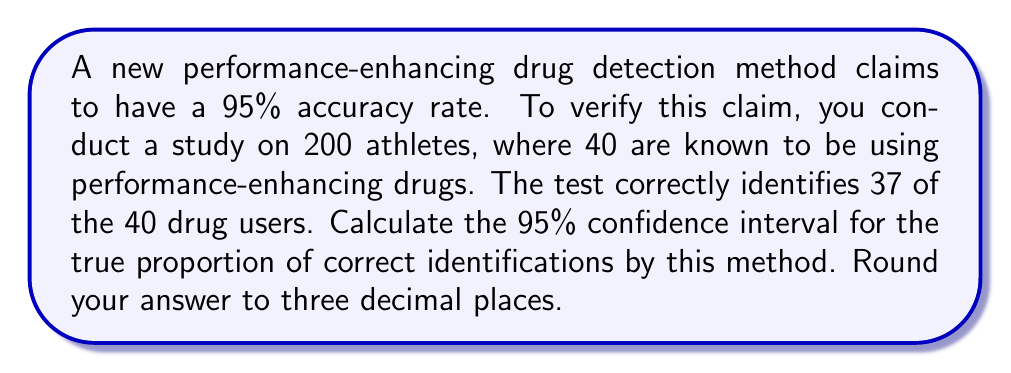Help me with this question. Let's approach this step-by-step:

1) First, we need to calculate the sample proportion (p̂):
   $\hat{p} = \frac{\text{number of correct identifications}}{\text{total number of known drug users}} = \frac{37}{40} = 0.925$

2) The formula for the confidence interval is:
   $$\hat{p} \pm z^* \sqrt{\frac{\hat{p}(1-\hat{p})}{n}}$$
   where $z^*$ is the critical value for a 95% confidence level (which is 1.96), and n is the sample size.

3) We know:
   $\hat{p} = 0.925$
   $n = 40$
   $z^* = 1.96$

4) Let's calculate the standard error:
   $$SE = \sqrt{\frac{\hat{p}(1-\hat{p})}{n}} = \sqrt{\frac{0.925(1-0.925)}{40}} = \sqrt{\frac{0.069375}{40}} = 0.0416$$

5) Now we can calculate the margin of error:
   $ME = z^* \times SE = 1.96 \times 0.0416 = 0.0815$

6) The confidence interval is therefore:
   $0.925 \pm 0.0815$

7) This gives us:
   Lower bound: $0.925 - 0.0815 = 0.8435$
   Upper bound: $0.925 + 0.0815 = 1.0065$

8) Since proportions cannot exceed 1, we cap the upper bound at 1.

9) Rounding to three decimal places, our final interval is [0.844, 1.000].
Answer: [0.844, 1.000] 